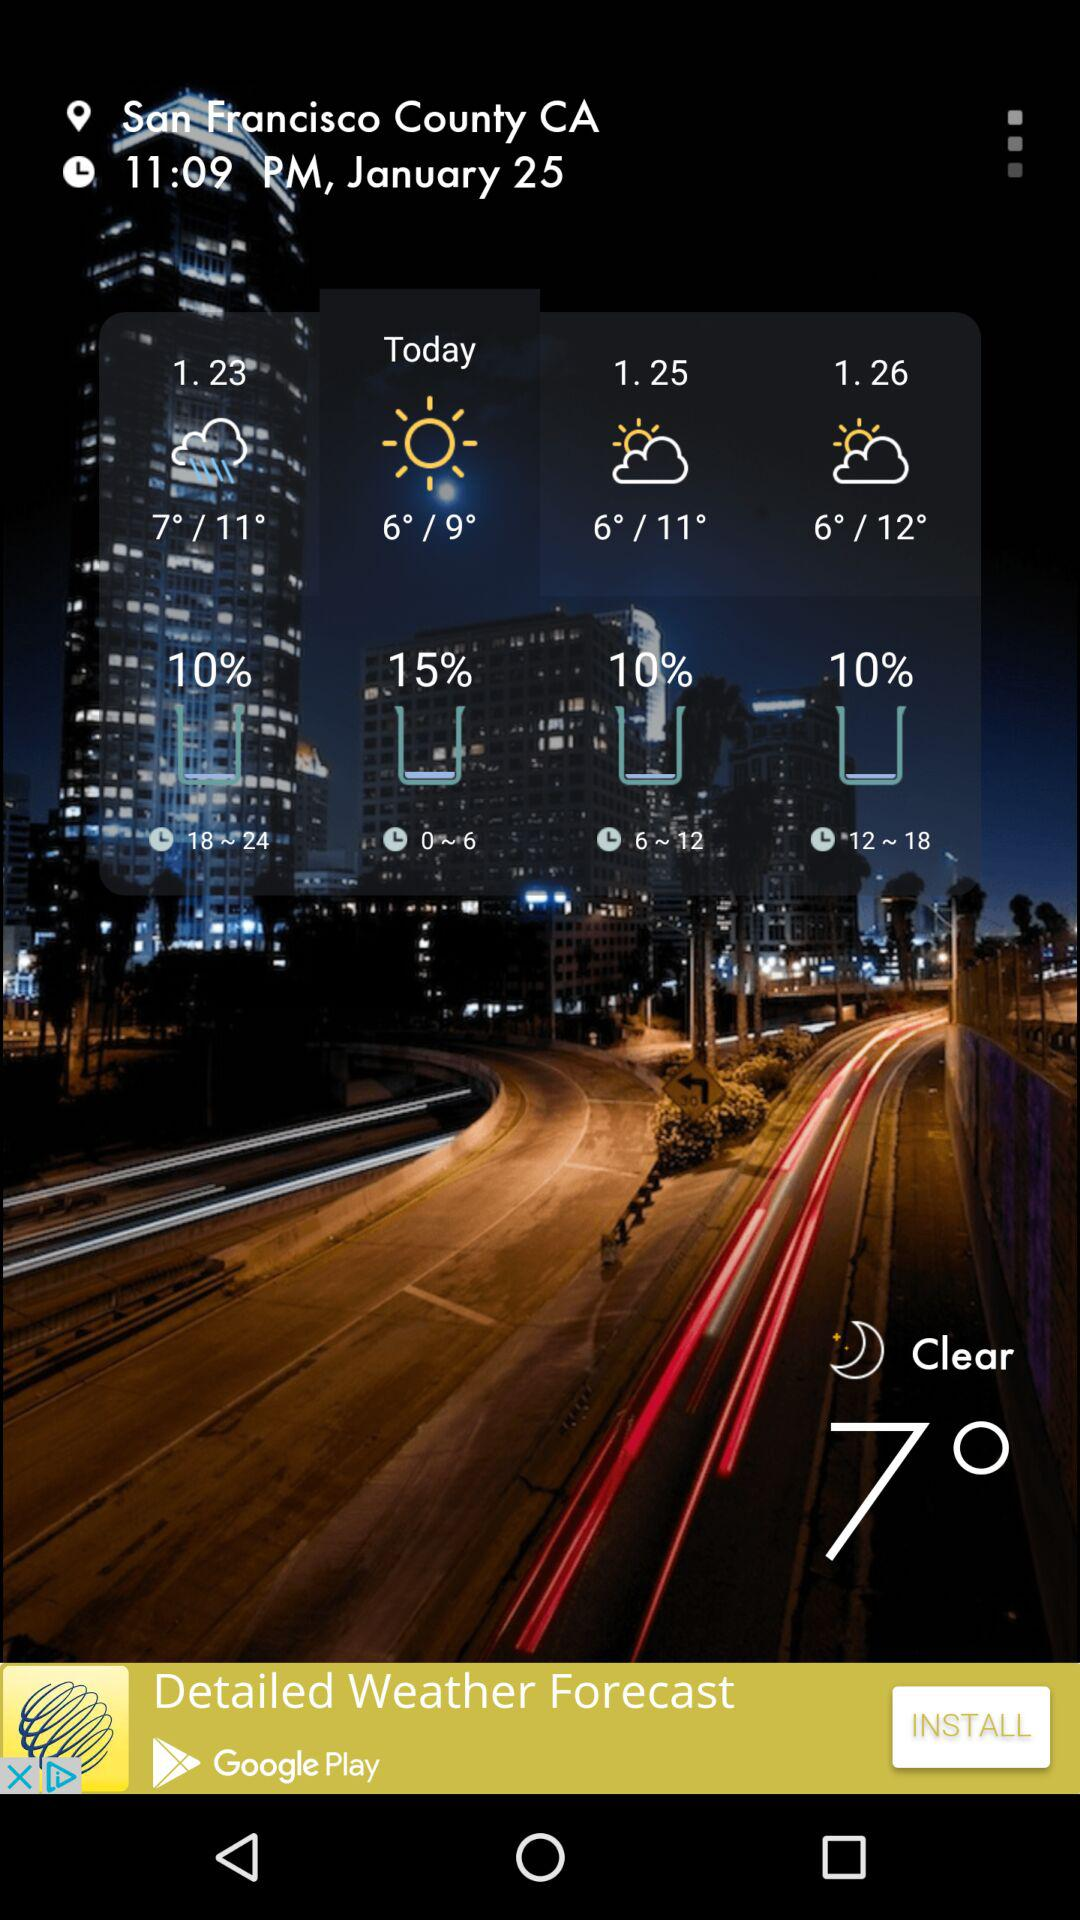What is the date? The date is January 25. 